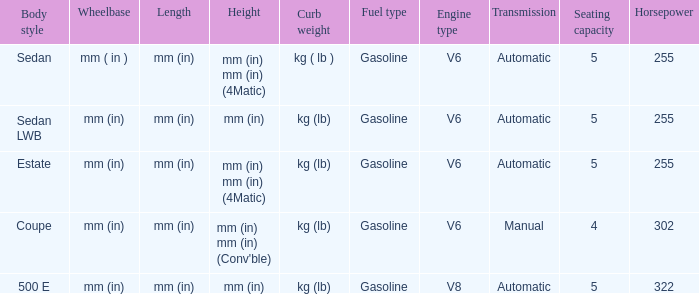What's the length of the model with Sedan body style? Mm (in). 